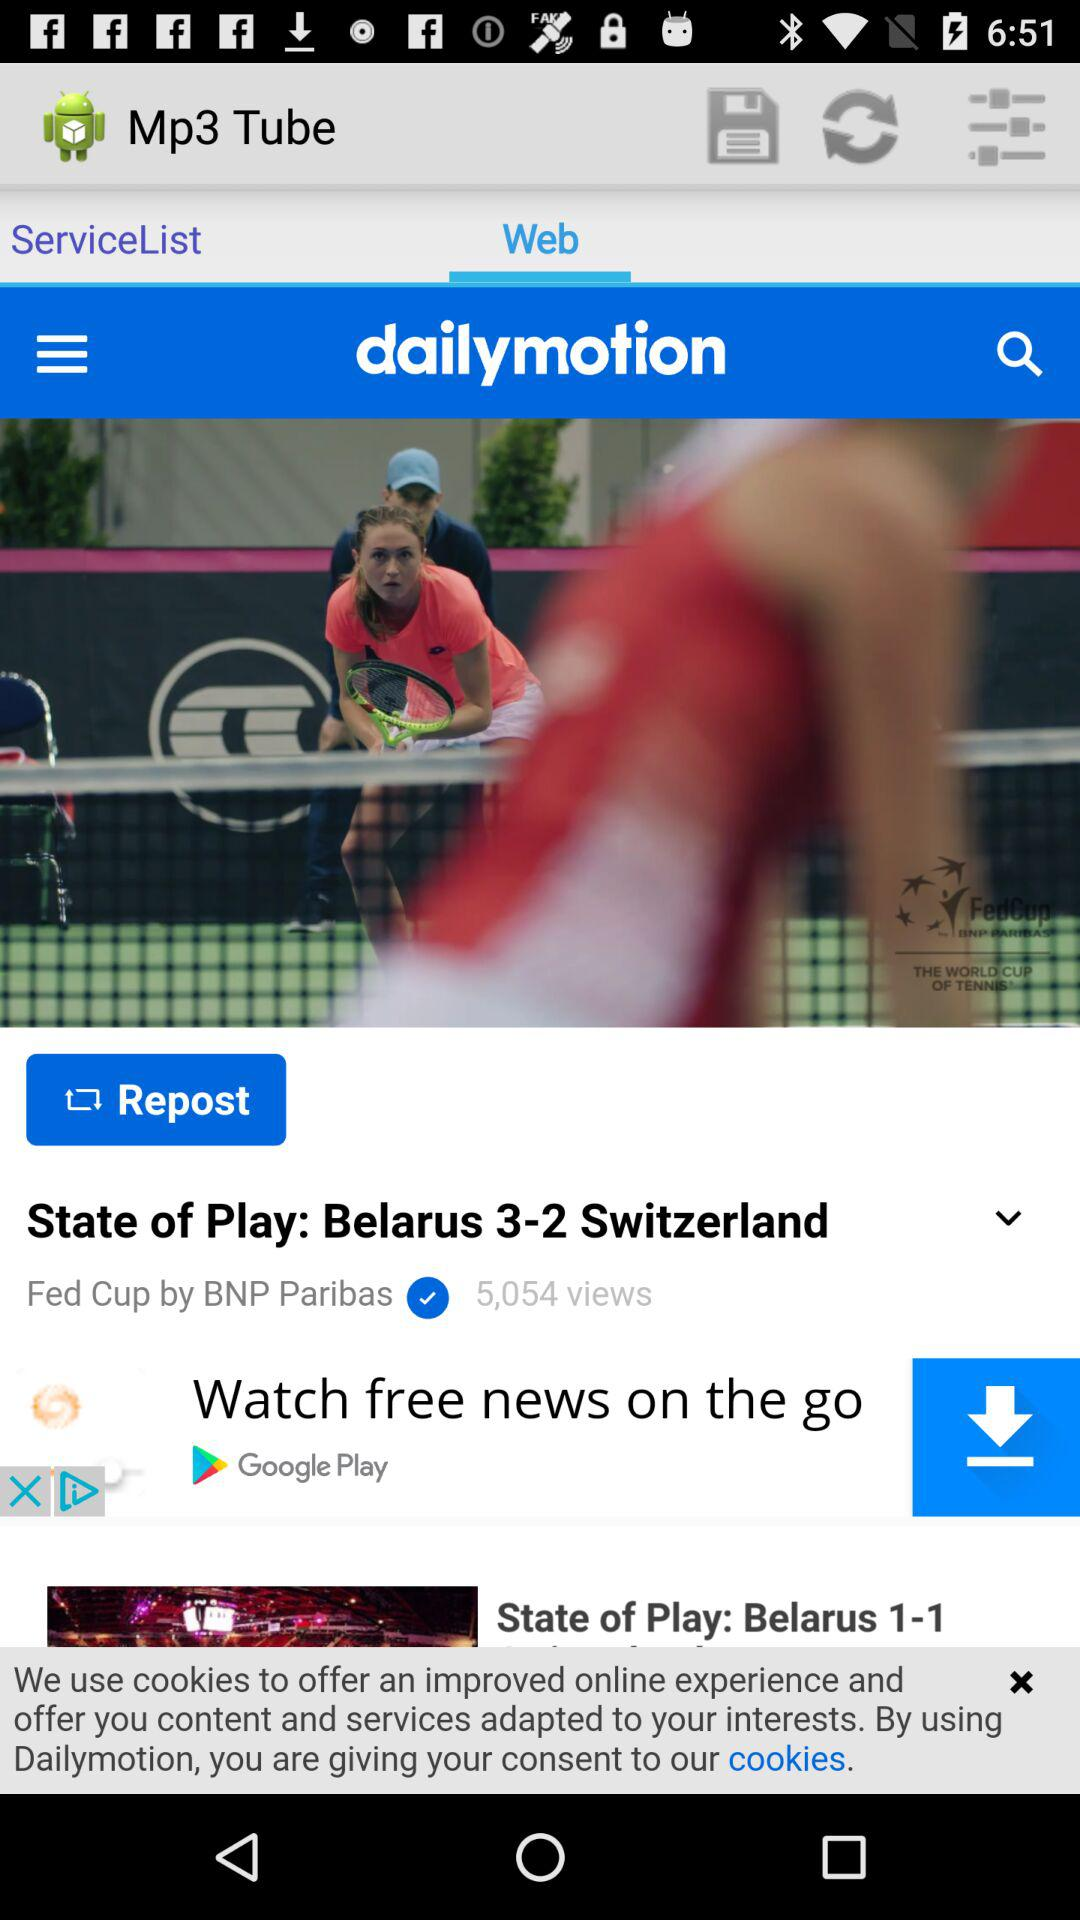How many views are there for the video 'State of Play: Belarus 3-2 Switzerland'?
Answer the question using a single word or phrase. 5,054 